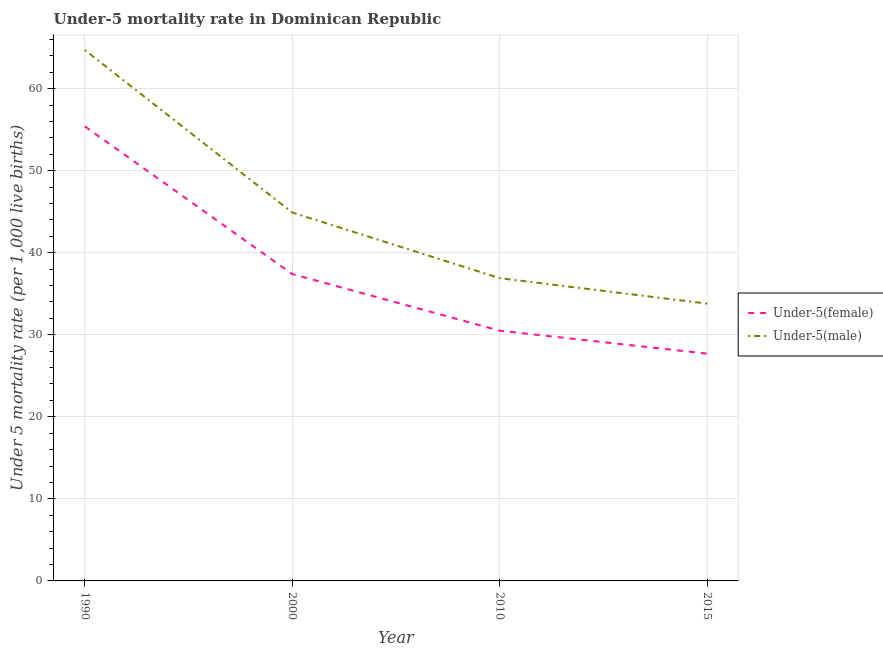What is the under-5 male mortality rate in 2010?
Offer a very short reply. 36.9. Across all years, what is the maximum under-5 male mortality rate?
Offer a terse response. 64.7. Across all years, what is the minimum under-5 male mortality rate?
Your response must be concise. 33.8. In which year was the under-5 female mortality rate maximum?
Make the answer very short. 1990. In which year was the under-5 male mortality rate minimum?
Offer a very short reply. 2015. What is the total under-5 female mortality rate in the graph?
Provide a succinct answer. 151. What is the difference between the under-5 male mortality rate in 1990 and that in 2015?
Your response must be concise. 30.9. What is the difference between the under-5 male mortality rate in 2015 and the under-5 female mortality rate in 2000?
Provide a short and direct response. -3.6. What is the average under-5 female mortality rate per year?
Offer a terse response. 37.75. In the year 2000, what is the difference between the under-5 female mortality rate and under-5 male mortality rate?
Provide a short and direct response. -7.5. What is the ratio of the under-5 female mortality rate in 1990 to that in 2010?
Your answer should be compact. 1.82. Is the under-5 female mortality rate in 1990 less than that in 2000?
Provide a short and direct response. No. What is the difference between the highest and the second highest under-5 male mortality rate?
Your answer should be compact. 19.8. What is the difference between the highest and the lowest under-5 male mortality rate?
Your response must be concise. 30.9. Is the under-5 male mortality rate strictly less than the under-5 female mortality rate over the years?
Offer a very short reply. No. How many lines are there?
Offer a very short reply. 2. How many years are there in the graph?
Make the answer very short. 4. Are the values on the major ticks of Y-axis written in scientific E-notation?
Your response must be concise. No. How many legend labels are there?
Provide a succinct answer. 2. How are the legend labels stacked?
Your response must be concise. Vertical. What is the title of the graph?
Ensure brevity in your answer.  Under-5 mortality rate in Dominican Republic. What is the label or title of the X-axis?
Offer a very short reply. Year. What is the label or title of the Y-axis?
Offer a very short reply. Under 5 mortality rate (per 1,0 live births). What is the Under 5 mortality rate (per 1,000 live births) in Under-5(female) in 1990?
Your answer should be compact. 55.4. What is the Under 5 mortality rate (per 1,000 live births) in Under-5(male) in 1990?
Provide a succinct answer. 64.7. What is the Under 5 mortality rate (per 1,000 live births) of Under-5(female) in 2000?
Your response must be concise. 37.4. What is the Under 5 mortality rate (per 1,000 live births) of Under-5(male) in 2000?
Offer a very short reply. 44.9. What is the Under 5 mortality rate (per 1,000 live births) of Under-5(female) in 2010?
Give a very brief answer. 30.5. What is the Under 5 mortality rate (per 1,000 live births) in Under-5(male) in 2010?
Offer a terse response. 36.9. What is the Under 5 mortality rate (per 1,000 live births) in Under-5(female) in 2015?
Offer a very short reply. 27.7. What is the Under 5 mortality rate (per 1,000 live births) in Under-5(male) in 2015?
Provide a short and direct response. 33.8. Across all years, what is the maximum Under 5 mortality rate (per 1,000 live births) of Under-5(female)?
Give a very brief answer. 55.4. Across all years, what is the maximum Under 5 mortality rate (per 1,000 live births) in Under-5(male)?
Your response must be concise. 64.7. Across all years, what is the minimum Under 5 mortality rate (per 1,000 live births) of Under-5(female)?
Your answer should be compact. 27.7. Across all years, what is the minimum Under 5 mortality rate (per 1,000 live births) in Under-5(male)?
Offer a terse response. 33.8. What is the total Under 5 mortality rate (per 1,000 live births) in Under-5(female) in the graph?
Provide a short and direct response. 151. What is the total Under 5 mortality rate (per 1,000 live births) of Under-5(male) in the graph?
Ensure brevity in your answer.  180.3. What is the difference between the Under 5 mortality rate (per 1,000 live births) in Under-5(female) in 1990 and that in 2000?
Give a very brief answer. 18. What is the difference between the Under 5 mortality rate (per 1,000 live births) in Under-5(male) in 1990 and that in 2000?
Your response must be concise. 19.8. What is the difference between the Under 5 mortality rate (per 1,000 live births) in Under-5(female) in 1990 and that in 2010?
Your answer should be very brief. 24.9. What is the difference between the Under 5 mortality rate (per 1,000 live births) in Under-5(male) in 1990 and that in 2010?
Make the answer very short. 27.8. What is the difference between the Under 5 mortality rate (per 1,000 live births) of Under-5(female) in 1990 and that in 2015?
Give a very brief answer. 27.7. What is the difference between the Under 5 mortality rate (per 1,000 live births) of Under-5(male) in 1990 and that in 2015?
Offer a very short reply. 30.9. What is the difference between the Under 5 mortality rate (per 1,000 live births) in Under-5(female) in 2000 and that in 2010?
Give a very brief answer. 6.9. What is the difference between the Under 5 mortality rate (per 1,000 live births) in Under-5(female) in 2000 and that in 2015?
Your answer should be compact. 9.7. What is the difference between the Under 5 mortality rate (per 1,000 live births) of Under-5(male) in 2000 and that in 2015?
Your answer should be very brief. 11.1. What is the difference between the Under 5 mortality rate (per 1,000 live births) of Under-5(female) in 1990 and the Under 5 mortality rate (per 1,000 live births) of Under-5(male) in 2010?
Make the answer very short. 18.5. What is the difference between the Under 5 mortality rate (per 1,000 live births) in Under-5(female) in 1990 and the Under 5 mortality rate (per 1,000 live births) in Under-5(male) in 2015?
Offer a terse response. 21.6. What is the difference between the Under 5 mortality rate (per 1,000 live births) in Under-5(female) in 2010 and the Under 5 mortality rate (per 1,000 live births) in Under-5(male) in 2015?
Ensure brevity in your answer.  -3.3. What is the average Under 5 mortality rate (per 1,000 live births) in Under-5(female) per year?
Offer a terse response. 37.75. What is the average Under 5 mortality rate (per 1,000 live births) of Under-5(male) per year?
Ensure brevity in your answer.  45.08. In the year 2000, what is the difference between the Under 5 mortality rate (per 1,000 live births) in Under-5(female) and Under 5 mortality rate (per 1,000 live births) in Under-5(male)?
Offer a terse response. -7.5. In the year 2010, what is the difference between the Under 5 mortality rate (per 1,000 live births) of Under-5(female) and Under 5 mortality rate (per 1,000 live births) of Under-5(male)?
Make the answer very short. -6.4. What is the ratio of the Under 5 mortality rate (per 1,000 live births) in Under-5(female) in 1990 to that in 2000?
Give a very brief answer. 1.48. What is the ratio of the Under 5 mortality rate (per 1,000 live births) of Under-5(male) in 1990 to that in 2000?
Provide a short and direct response. 1.44. What is the ratio of the Under 5 mortality rate (per 1,000 live births) of Under-5(female) in 1990 to that in 2010?
Your response must be concise. 1.82. What is the ratio of the Under 5 mortality rate (per 1,000 live births) of Under-5(male) in 1990 to that in 2010?
Make the answer very short. 1.75. What is the ratio of the Under 5 mortality rate (per 1,000 live births) of Under-5(female) in 1990 to that in 2015?
Ensure brevity in your answer.  2. What is the ratio of the Under 5 mortality rate (per 1,000 live births) of Under-5(male) in 1990 to that in 2015?
Ensure brevity in your answer.  1.91. What is the ratio of the Under 5 mortality rate (per 1,000 live births) of Under-5(female) in 2000 to that in 2010?
Your answer should be very brief. 1.23. What is the ratio of the Under 5 mortality rate (per 1,000 live births) in Under-5(male) in 2000 to that in 2010?
Provide a short and direct response. 1.22. What is the ratio of the Under 5 mortality rate (per 1,000 live births) in Under-5(female) in 2000 to that in 2015?
Keep it short and to the point. 1.35. What is the ratio of the Under 5 mortality rate (per 1,000 live births) of Under-5(male) in 2000 to that in 2015?
Provide a short and direct response. 1.33. What is the ratio of the Under 5 mortality rate (per 1,000 live births) of Under-5(female) in 2010 to that in 2015?
Your answer should be compact. 1.1. What is the ratio of the Under 5 mortality rate (per 1,000 live births) in Under-5(male) in 2010 to that in 2015?
Provide a succinct answer. 1.09. What is the difference between the highest and the second highest Under 5 mortality rate (per 1,000 live births) in Under-5(female)?
Provide a succinct answer. 18. What is the difference between the highest and the second highest Under 5 mortality rate (per 1,000 live births) of Under-5(male)?
Offer a very short reply. 19.8. What is the difference between the highest and the lowest Under 5 mortality rate (per 1,000 live births) of Under-5(female)?
Your answer should be very brief. 27.7. What is the difference between the highest and the lowest Under 5 mortality rate (per 1,000 live births) of Under-5(male)?
Your answer should be very brief. 30.9. 